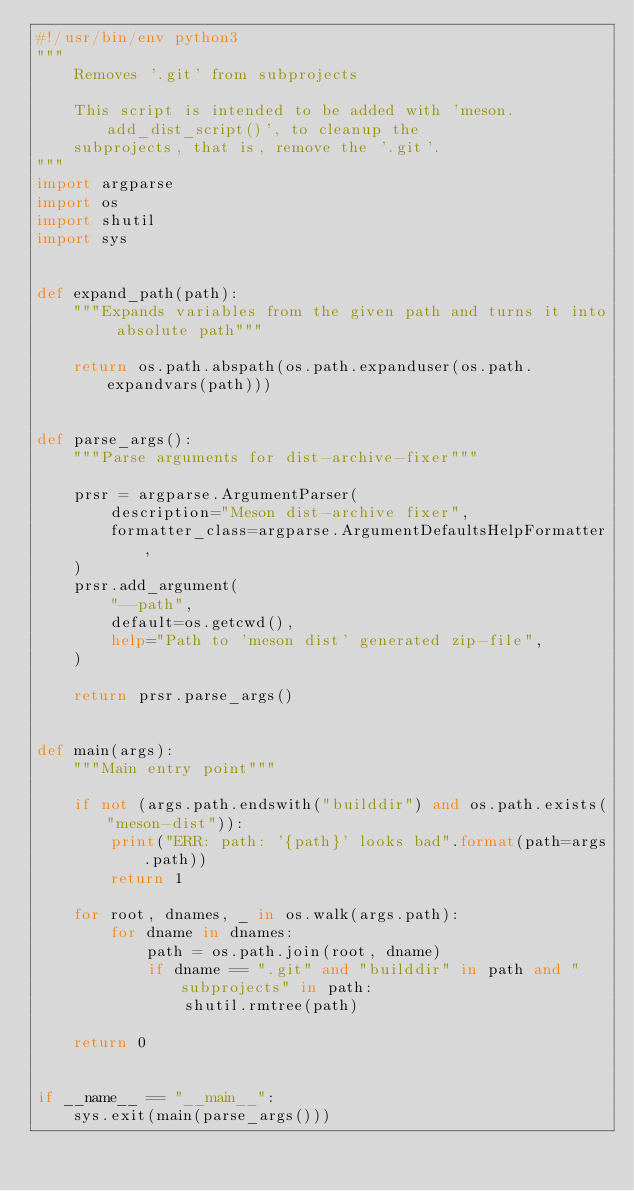<code> <loc_0><loc_0><loc_500><loc_500><_Python_>#!/usr/bin/env python3
"""
    Removes '.git' from subprojects

    This script is intended to be added with 'meson.add_dist_script()', to cleanup the
    subprojects, that is, remove the '.git'.
"""
import argparse
import os
import shutil
import sys


def expand_path(path):
    """Expands variables from the given path and turns it into absolute path"""

    return os.path.abspath(os.path.expanduser(os.path.expandvars(path)))


def parse_args():
    """Parse arguments for dist-archive-fixer"""

    prsr = argparse.ArgumentParser(
        description="Meson dist-archive fixer",
        formatter_class=argparse.ArgumentDefaultsHelpFormatter,
    )
    prsr.add_argument(
        "--path",
        default=os.getcwd(),
        help="Path to 'meson dist' generated zip-file",
    )

    return prsr.parse_args()


def main(args):
    """Main entry point"""

    if not (args.path.endswith("builddir") and os.path.exists("meson-dist")):
        print("ERR: path: '{path}' looks bad".format(path=args.path))
        return 1

    for root, dnames, _ in os.walk(args.path):
        for dname in dnames:
            path = os.path.join(root, dname)
            if dname == ".git" and "builddir" in path and "subprojects" in path:
                shutil.rmtree(path)

    return 0


if __name__ == "__main__":
    sys.exit(main(parse_args()))
</code> 